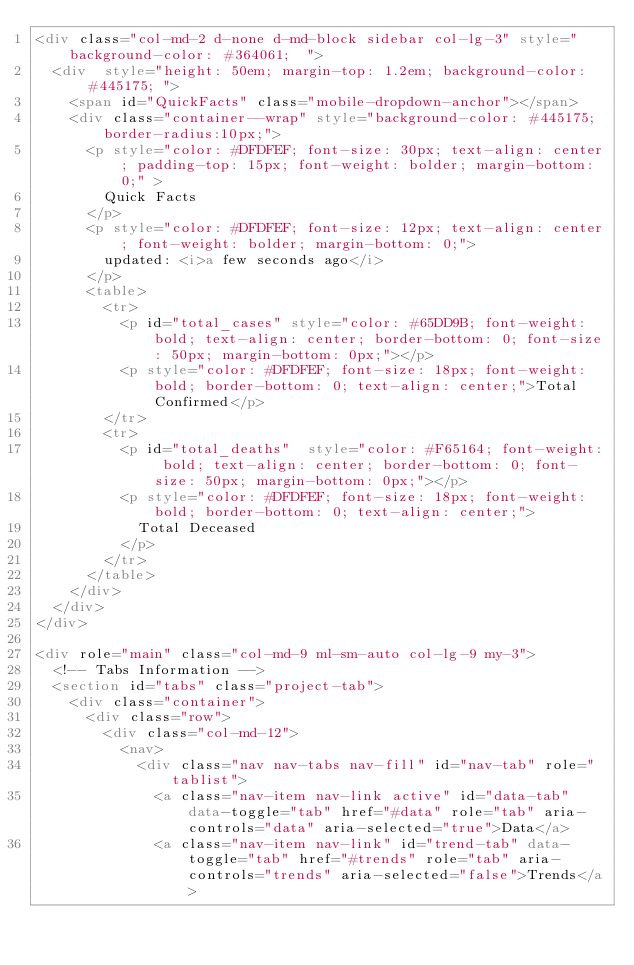<code> <loc_0><loc_0><loc_500><loc_500><_HTML_><div class="col-md-2 d-none d-md-block sidebar col-lg-3" style="background-color: #364061;  ">
	<div  style="height: 50em; margin-top: 1.2em; background-color: #445175; ">
		<span id="QuickFacts" class="mobile-dropdown-anchor"></span>
		<div class="container--wrap" style="background-color: #445175; border-radius:10px;">
			<p style="color: #DFDFEF; font-size: 30px; text-align: center; padding-top: 15px; font-weight: bolder; margin-bottom: 0;" >
				Quick Facts
			</p>
			<p style="color: #DFDFEF; font-size: 12px; text-align: center; font-weight: bolder; margin-bottom: 0;">
				updated: <i>a few seconds ago</i>
			</p>
			<table>
				<tr>
					<p id="total_cases" style="color: #65DD9B; font-weight: bold; text-align: center; border-bottom: 0; font-size: 50px; margin-bottom: 0px;"></p>
					<p style="color: #DFDFEF; font-size: 18px; font-weight: bold; border-bottom: 0; text-align: center;">Total Confirmed</p>
				</tr>
				<tr>
					<p id="total_deaths"  style="color: #F65164; font-weight: bold; text-align: center; border-bottom: 0; font-size: 50px; margin-bottom: 0px;"></p>
					<p style="color: #DFDFEF; font-size: 18px; font-weight: bold; border-bottom: 0; text-align: center;">
						Total Deceased
					</p>
				</tr>
			</table>
		</div>
	</div>
</div>

<div role="main" class="col-md-9 ml-sm-auto col-lg-9 my-3">
	<!-- Tabs Information -->
	<section id="tabs" class="project-tab">
		<div class="container">
			<div class="row">
				<div class="col-md-12">
					<nav>
						<div class="nav nav-tabs nav-fill" id="nav-tab" role="tablist">
							<a class="nav-item nav-link active" id="data-tab" data-toggle="tab" href="#data" role="tab" aria-controls="data" aria-selected="true">Data</a>
							<a class="nav-item nav-link" id="trend-tab" data-toggle="tab" href="#trends" role="tab" aria-controls="trends" aria-selected="false">Trends</a></code> 